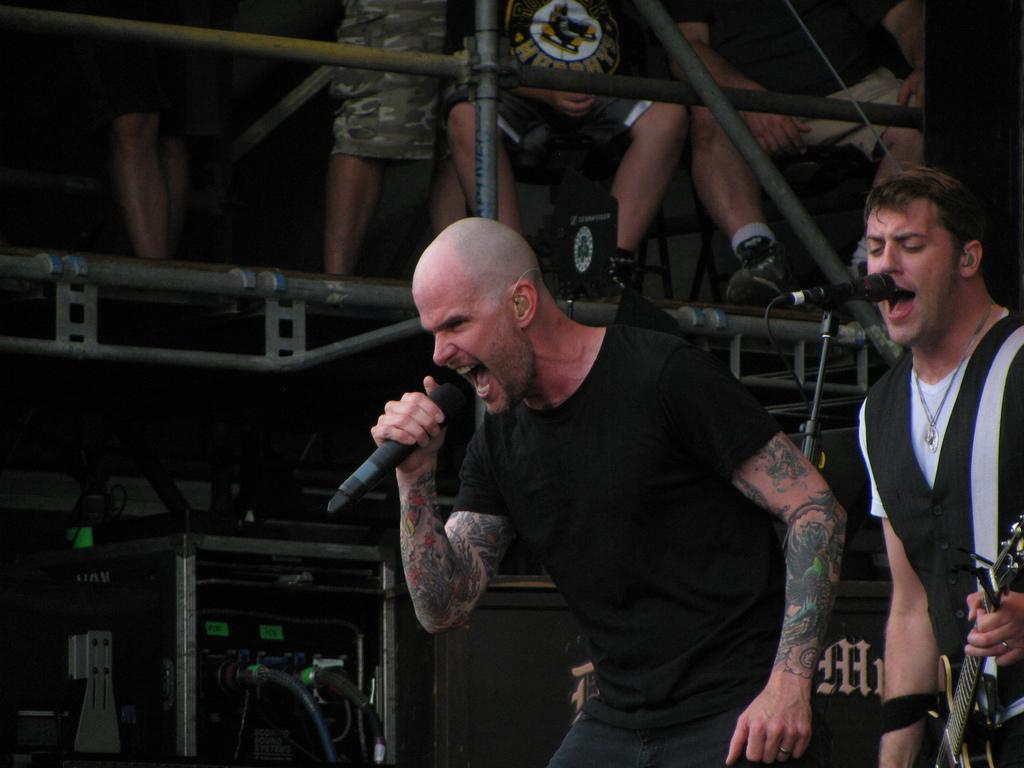In one or two sentences, can you explain what this image depicts? In this picture we can see two men where one is holding guitar in his hand and other is holding mic in his hand and they both are singing on mic and in background we can see some persons sitting, fence, speakers, devices, wires. 